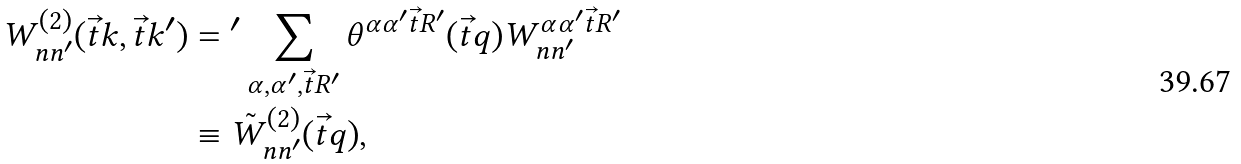Convert formula to latex. <formula><loc_0><loc_0><loc_500><loc_500>W ^ { ( 2 ) } _ { n n ^ { \prime } } ( \vec { t } { k } , \vec { t } { k } ^ { \prime } ) & = { ^ { \prime } } \sum _ { \alpha , \alpha ^ { \prime } , \vec { t } { R } ^ { \prime } } \theta ^ { \alpha \alpha ^ { \prime } \vec { t } { R } ^ { \prime } } ( \vec { t } { q } ) W ^ { \alpha \alpha ^ { \prime } \vec { t } { R } ^ { \prime } } _ { n n ^ { \prime } } \\ & \equiv \tilde { W } ^ { ( 2 ) } _ { n n ^ { \prime } } ( \vec { t } { q } ) ,</formula> 